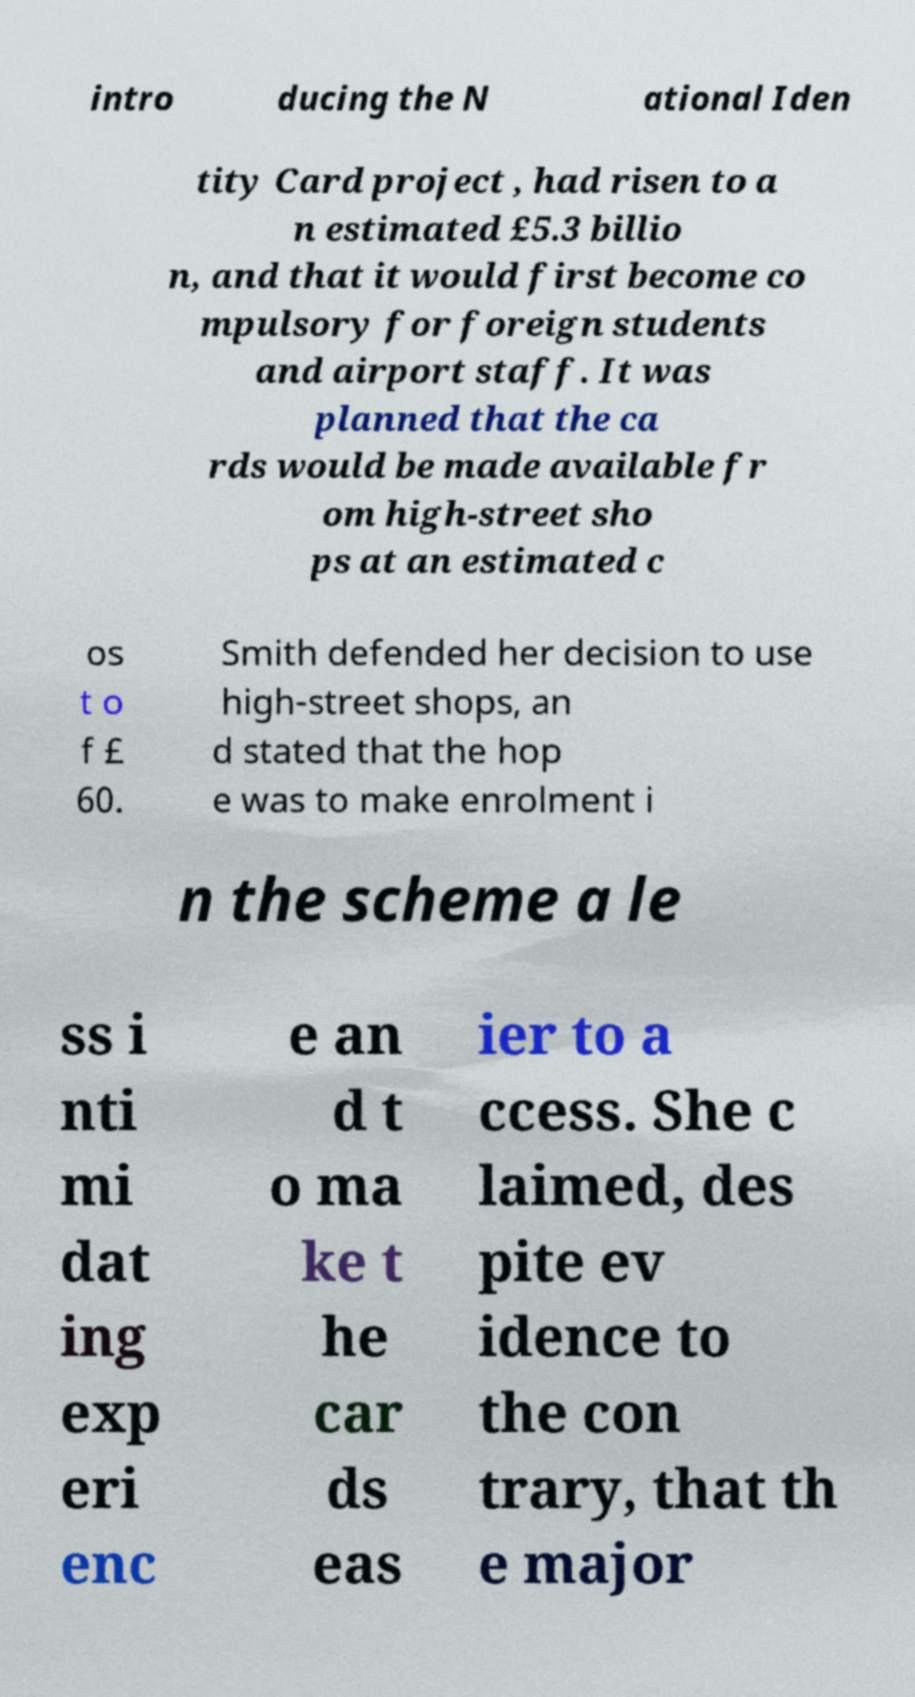Can you read and provide the text displayed in the image?This photo seems to have some interesting text. Can you extract and type it out for me? intro ducing the N ational Iden tity Card project , had risen to a n estimated £5.3 billio n, and that it would first become co mpulsory for foreign students and airport staff. It was planned that the ca rds would be made available fr om high-street sho ps at an estimated c os t o f £ 60. Smith defended her decision to use high-street shops, an d stated that the hop e was to make enrolment i n the scheme a le ss i nti mi dat ing exp eri enc e an d t o ma ke t he car ds eas ier to a ccess. She c laimed, des pite ev idence to the con trary, that th e major 